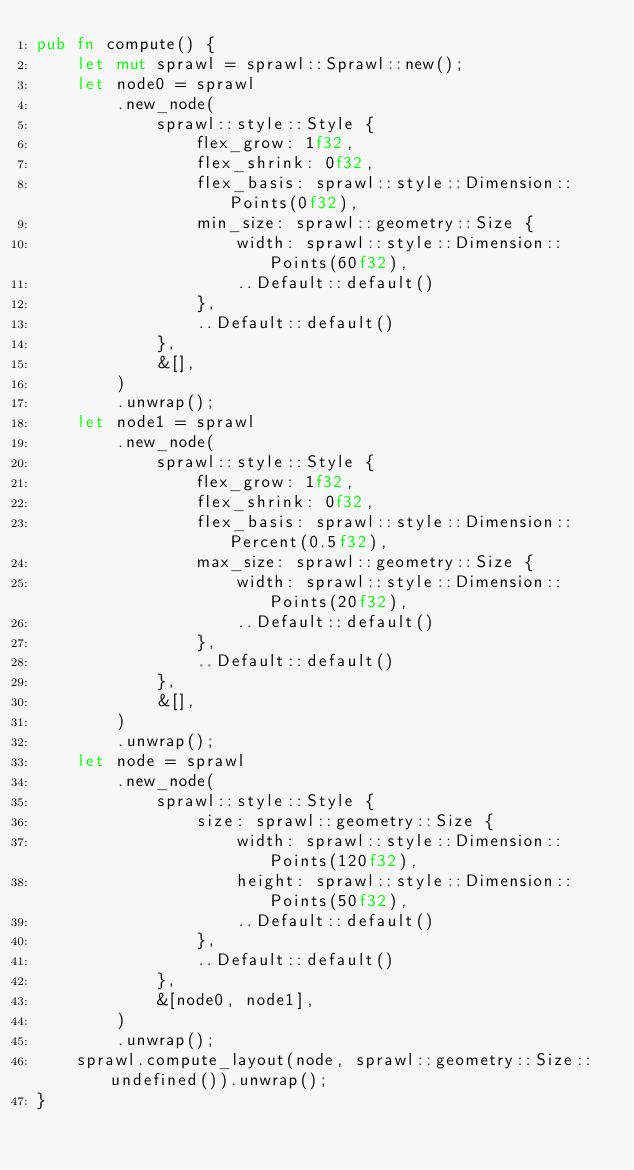<code> <loc_0><loc_0><loc_500><loc_500><_Rust_>pub fn compute() {
    let mut sprawl = sprawl::Sprawl::new();
    let node0 = sprawl
        .new_node(
            sprawl::style::Style {
                flex_grow: 1f32,
                flex_shrink: 0f32,
                flex_basis: sprawl::style::Dimension::Points(0f32),
                min_size: sprawl::geometry::Size {
                    width: sprawl::style::Dimension::Points(60f32),
                    ..Default::default()
                },
                ..Default::default()
            },
            &[],
        )
        .unwrap();
    let node1 = sprawl
        .new_node(
            sprawl::style::Style {
                flex_grow: 1f32,
                flex_shrink: 0f32,
                flex_basis: sprawl::style::Dimension::Percent(0.5f32),
                max_size: sprawl::geometry::Size {
                    width: sprawl::style::Dimension::Points(20f32),
                    ..Default::default()
                },
                ..Default::default()
            },
            &[],
        )
        .unwrap();
    let node = sprawl
        .new_node(
            sprawl::style::Style {
                size: sprawl::geometry::Size {
                    width: sprawl::style::Dimension::Points(120f32),
                    height: sprawl::style::Dimension::Points(50f32),
                    ..Default::default()
                },
                ..Default::default()
            },
            &[node0, node1],
        )
        .unwrap();
    sprawl.compute_layout(node, sprawl::geometry::Size::undefined()).unwrap();
}
</code> 